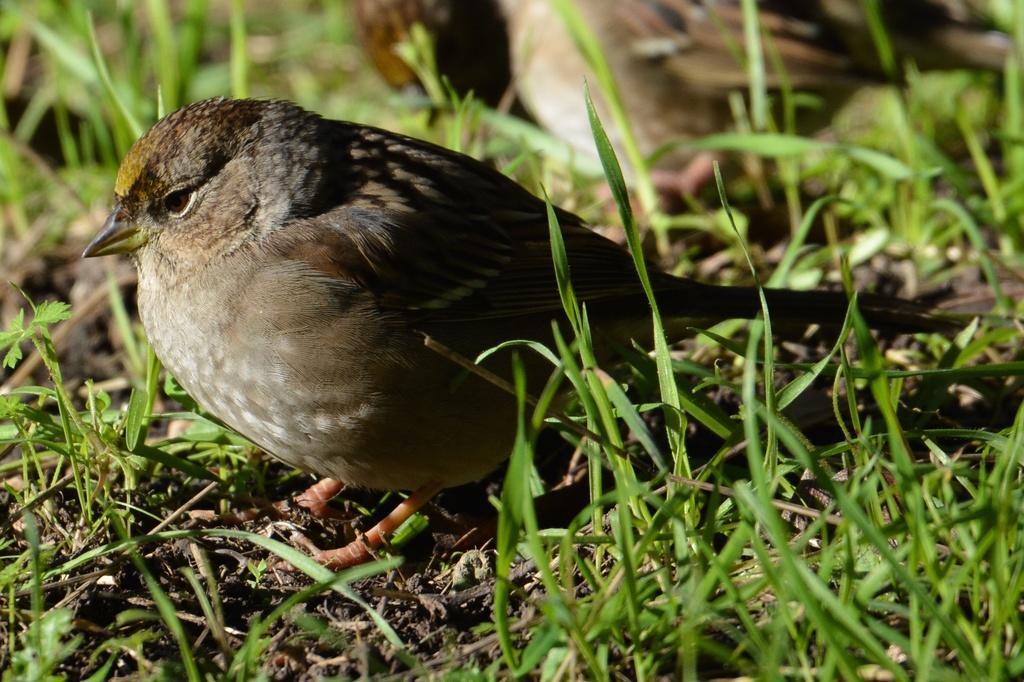In one or two sentences, can you explain what this image depicts? In this picture we can see a bird on the land, around we can see some grass. 